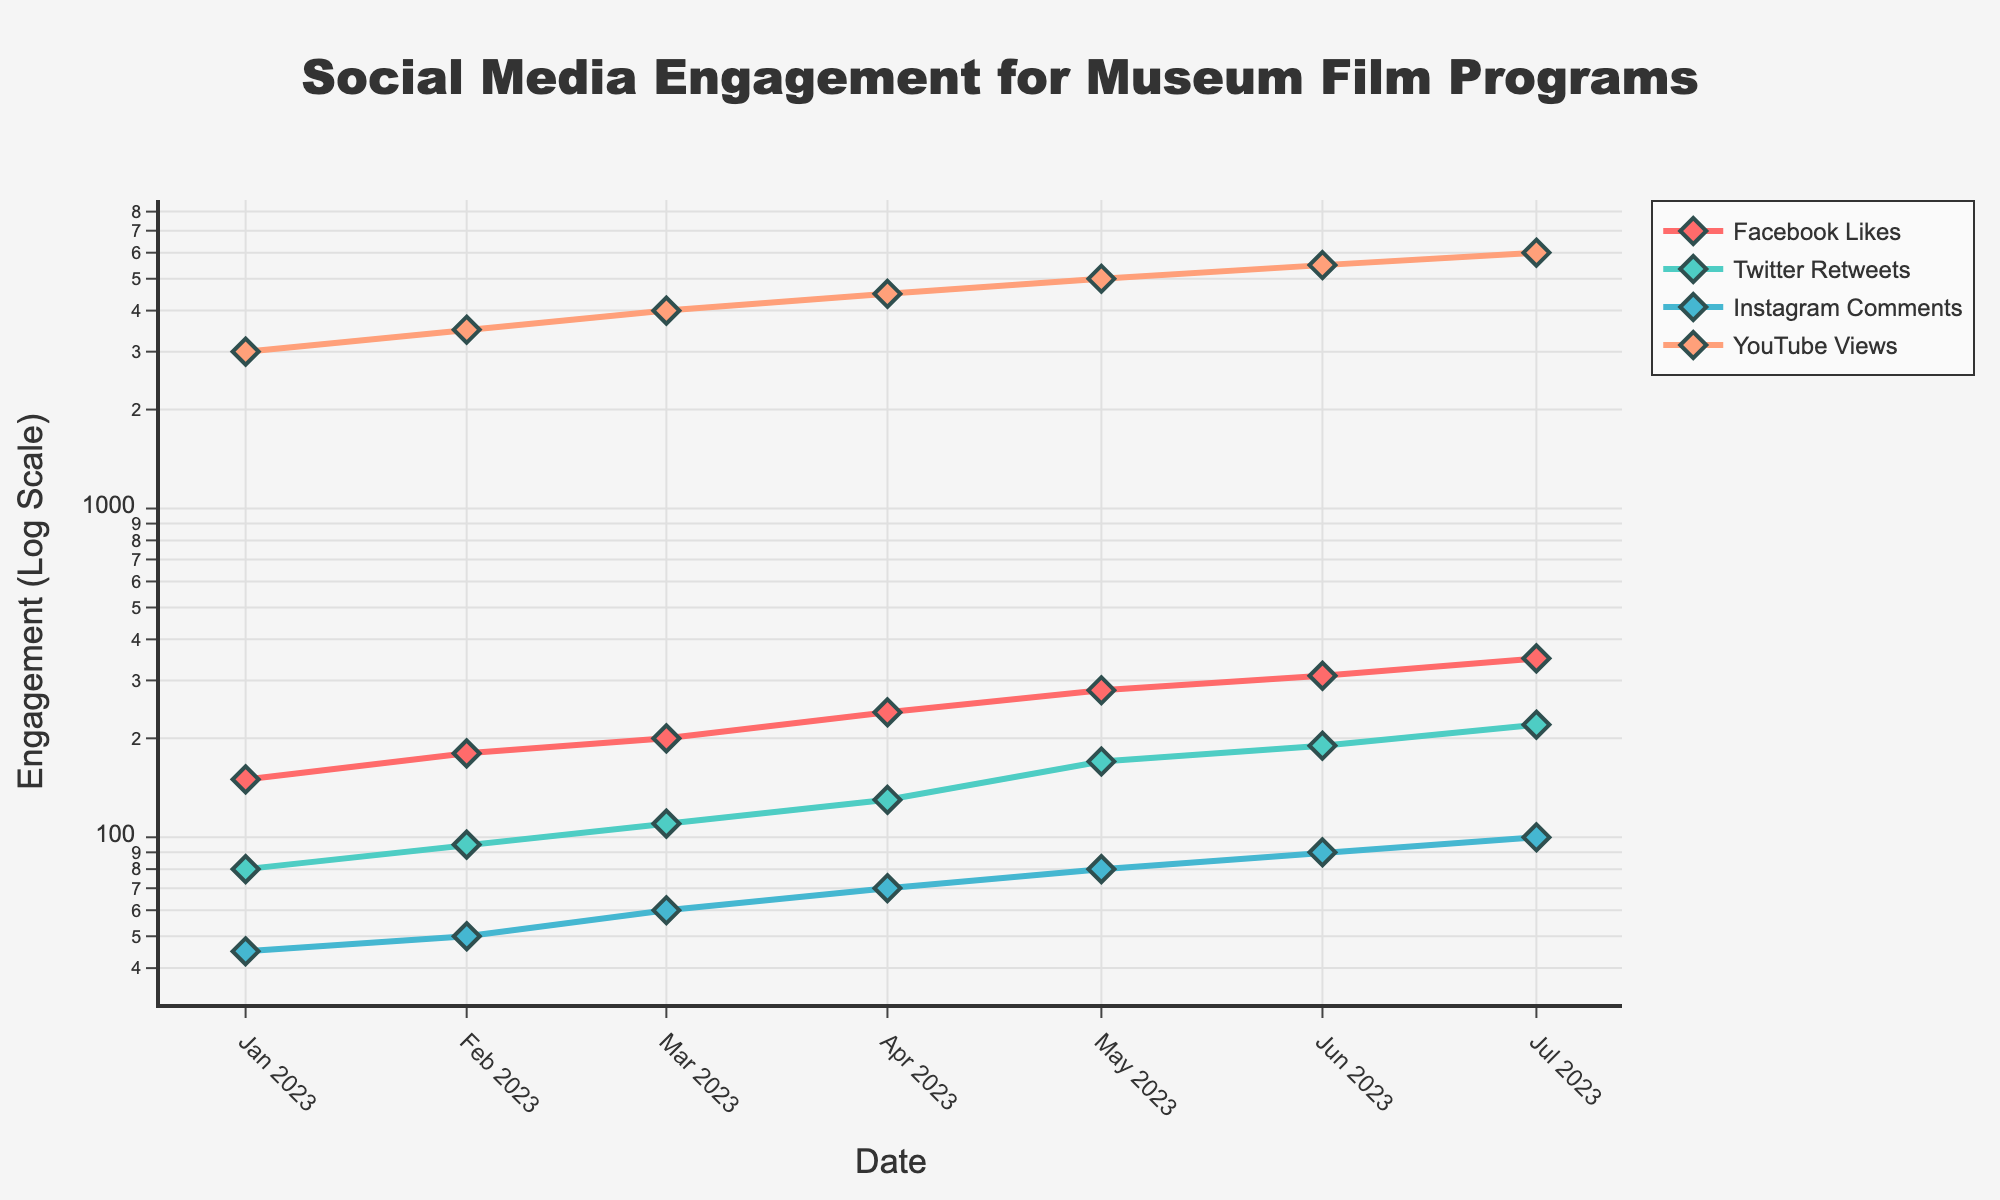What's the title of the plot? The title is located at the top center of the plot. It reads "Social Media Engagement for Museum Film Programs".
Answer: Social Media Engagement for Museum Film Programs Which social media metric has the highest engagement in July 2023? To find the highest engagement in July 2023, locate the data point for July 2023 on the x-axis and compare the four metrics. The tallest value corresponds to YouTube Views.
Answer: YouTube Views By how much did Facebook Likes increase from January to July 2023? Locate the data points for Facebook Likes in January and July 2023. Subtract the January value (150) from the July value (350).
Answer: 200 How many different social media metrics are tracked in this plot? Count the number of different traces indicated by the legend. There are four different social media metrics.
Answer: 4 Which month saw the highest increase in Instagram Comments compared to the previous month? Analyze the points for Instagram Comments each month and determine the month with the largest vertical gap between two consecutive points. The largest increase is observed between March and April.
Answer: April What is the color used for the Twitter Retweets trace? Refer to the legend to identify the color associated with Twitter Retweets. The color is a shade of green.
Answer: Green What is the growth rate of YouTube Views from January 2023 to July 2023? Calculate the difference in YouTube Views from January (3000) to July (6000) and then divide by the initial value (January). The growth rate formula is (6000 - 3000) / 3000 = 1 or 100%.
Answer: 100% Which metric shows the steepest overall increase over the entire time period? Observe the slope of each metric from January to July. The metric with the consistently steepest slope is Facebook Likes.
Answer: Facebook Likes What's the total engagement of all metrics in May 2023? Sum the values of all metrics in May 2023. Facebook Likes (280) + Twitter Retweets (170) + Instagram Comments (80) + YouTube Views (5000).
Answer: 5530 